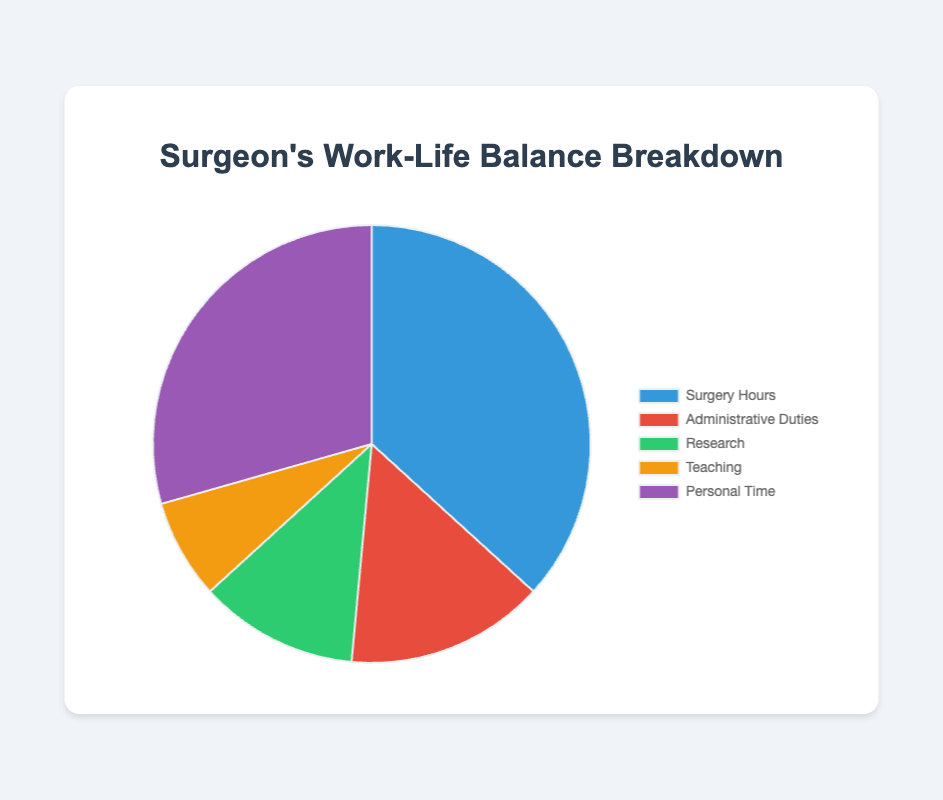How many hours per week are spent on Research and Teaching combined? Add the hours spent on Research (8 hours) and Teaching (5 hours). 8 + 5 = 13
Answer: 13 Which category has the highest number of hours per week? By inspecting the pie chart, the largest section corresponds to Surgery Hours with 25 hours per week.
Answer: Surgery Hours What is the percentage of time spent on Administrative Duties considering a 68-hour work week? The total sum of hours is 25+10+8+5+20=68. The percentage is calculated as (10/68) * 100 ≈ 14.71%.
Answer: 14.71% Are there more hours spent on Administrative Duties or Research? Comparing Administrative Duties (10 hours) with Research (8 hours), Administrative Duties has more hours.
Answer: Administrative Duties What is the difference in hours per week between Personal Time and Surgery Hours? Subtract the hours for Surgery Hours (25) from Personal Time (20). 20 - 25 = -5. The difference is 5 hours more for Surgery Hours.
Answer: 5 What fraction of the total time is spent teaching? The fraction is calculated as Teaching hours (5) over the total hours (68). 5/68 ≈ 0.0735 or approximately 1/13.
Answer: 1/13 What are the two smallest categories in terms of hours per week? The two smallest categories are Research (8 hours) and Teaching (5 hours).
Answer: Research and Teaching How does the time spent on Personal Time compare with the combined time for Research and Administrative Duties? Personal Time is 20 hours, combining Research (8) and Administrative (10) gives 18. 20 > 18, meaning more time is spent on Personal Time.
Answer: Personal Time What is the average number of hours per week spent on Surgery Hours, Administrative Duties, and Research? Add the hours for Surgery Hours (25), Administrative Duties (10), and Research (8) then divide by the number of categories. (25+10+8)/3 = 43/3 ≈ 14.33
Answer: 14.33 